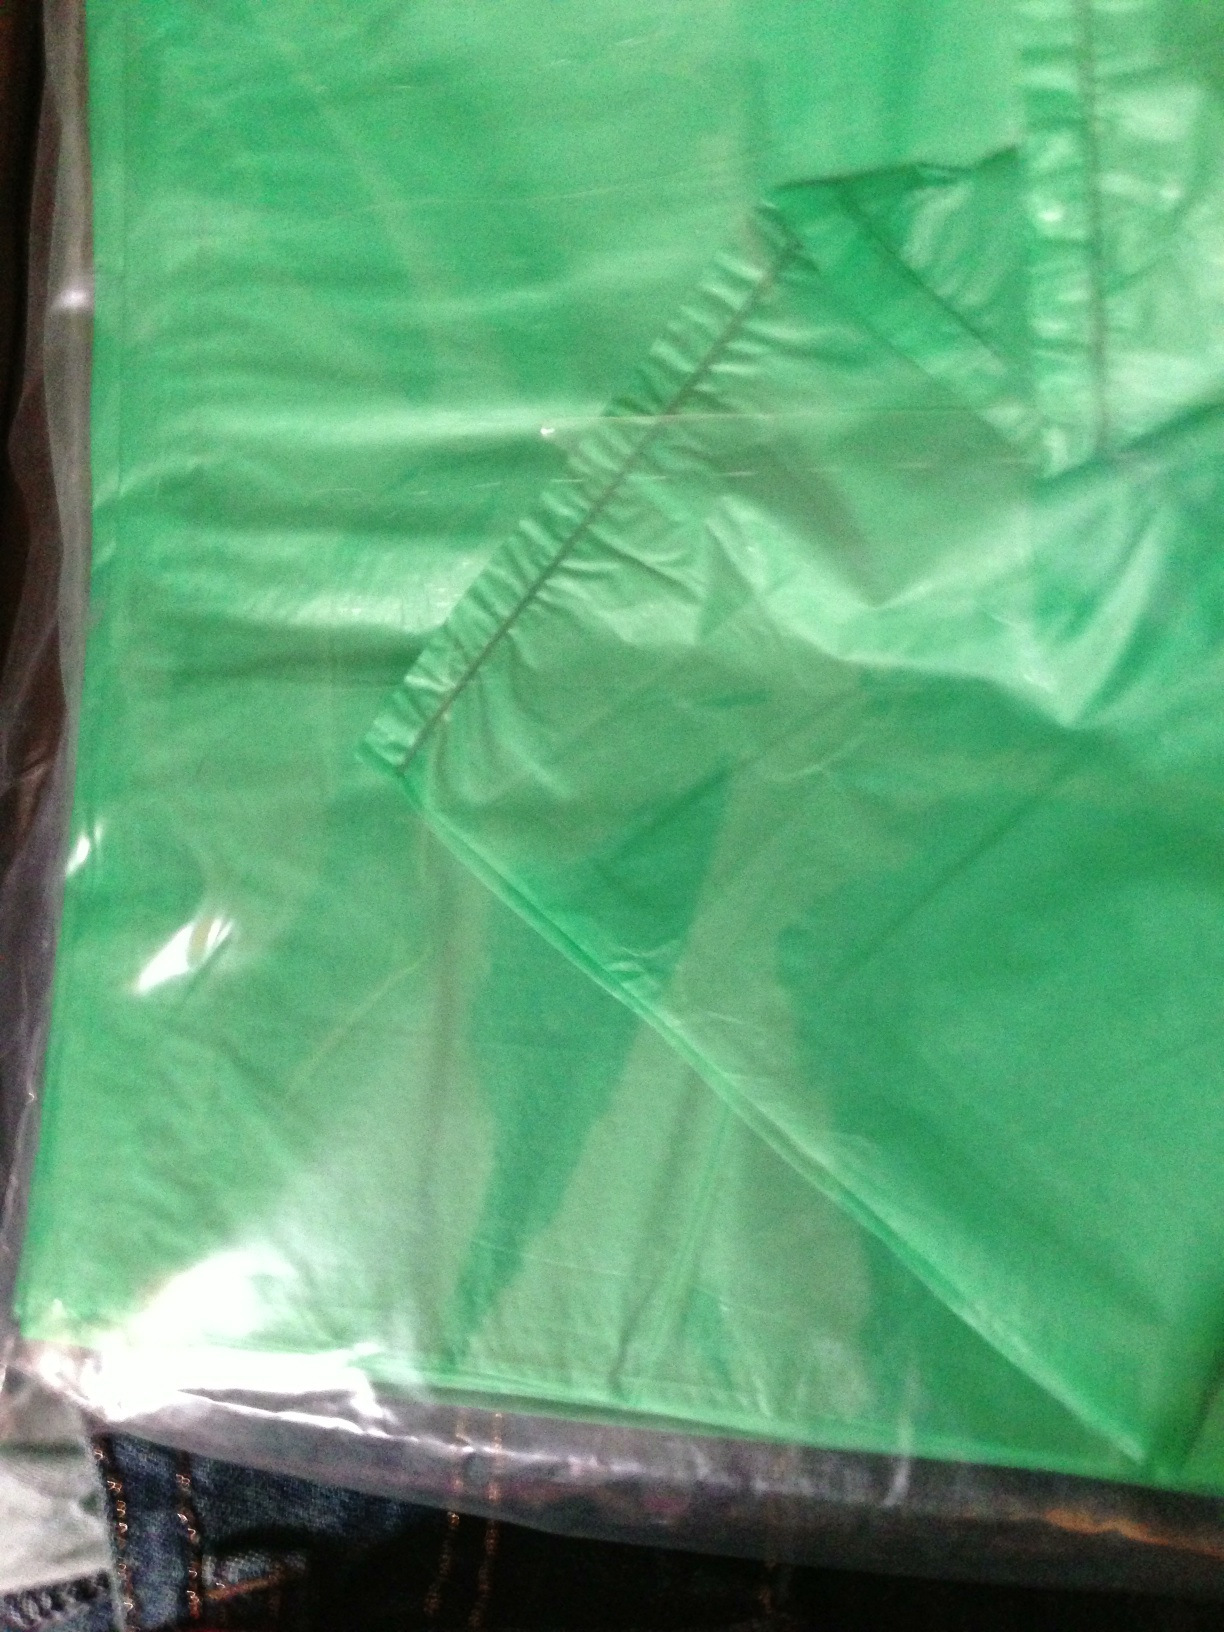Is this bag suitable for grocery shopping? Given its size and material, this bag looks suitable for grocery shopping. It appears to be durable and quite spacious, which would be handy for carrying a variety of grocery items. 